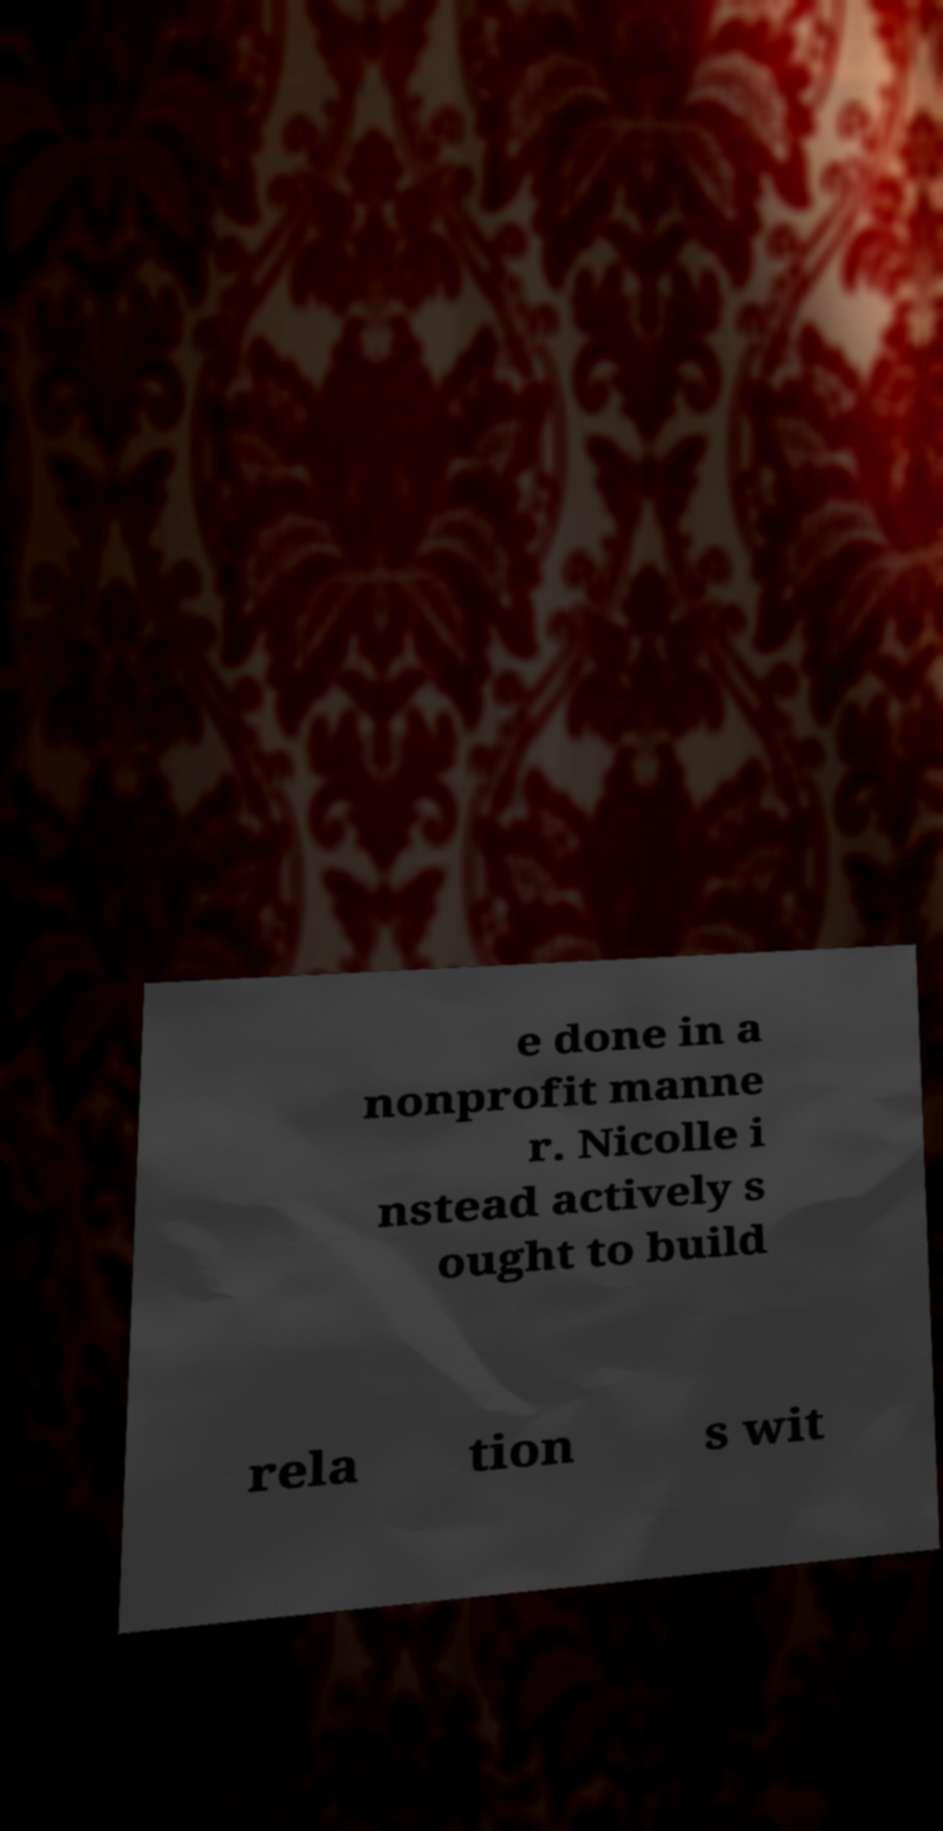What messages or text are displayed in this image? I need them in a readable, typed format. e done in a nonprofit manne r. Nicolle i nstead actively s ought to build rela tion s wit 